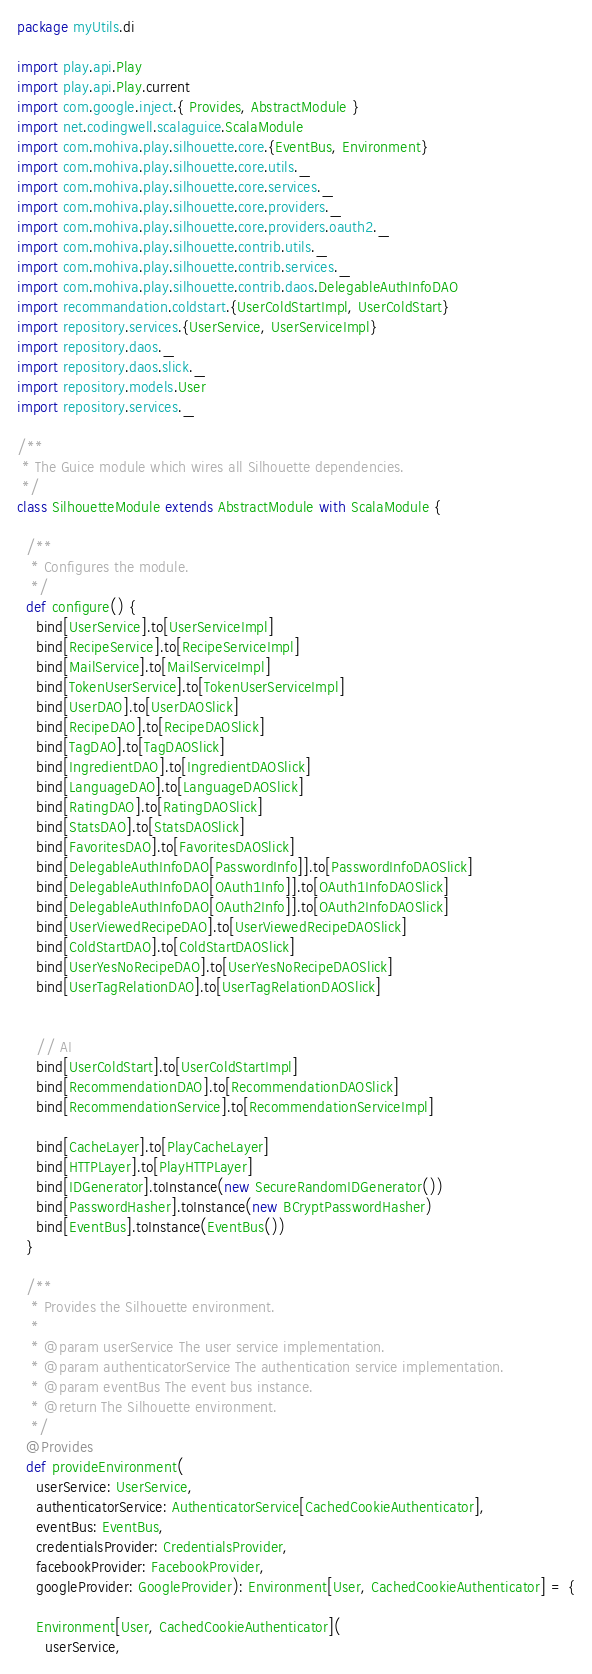Convert code to text. <code><loc_0><loc_0><loc_500><loc_500><_Scala_>package myUtils.di

import play.api.Play
import play.api.Play.current
import com.google.inject.{ Provides, AbstractModule }
import net.codingwell.scalaguice.ScalaModule
import com.mohiva.play.silhouette.core.{EventBus, Environment}
import com.mohiva.play.silhouette.core.utils._
import com.mohiva.play.silhouette.core.services._
import com.mohiva.play.silhouette.core.providers._
import com.mohiva.play.silhouette.core.providers.oauth2._
import com.mohiva.play.silhouette.contrib.utils._
import com.mohiva.play.silhouette.contrib.services._
import com.mohiva.play.silhouette.contrib.daos.DelegableAuthInfoDAO
import recommandation.coldstart.{UserColdStartImpl, UserColdStart}
import repository.services.{UserService, UserServiceImpl}
import repository.daos._
import repository.daos.slick._
import repository.models.User
import repository.services._

/**
 * The Guice module which wires all Silhouette dependencies.
 */
class SilhouetteModule extends AbstractModule with ScalaModule {

  /**
   * Configures the module.
   */
  def configure() {
    bind[UserService].to[UserServiceImpl]
    bind[RecipeService].to[RecipeServiceImpl]
    bind[MailService].to[MailServiceImpl]
    bind[TokenUserService].to[TokenUserServiceImpl]
    bind[UserDAO].to[UserDAOSlick]
    bind[RecipeDAO].to[RecipeDAOSlick]
    bind[TagDAO].to[TagDAOSlick]
    bind[IngredientDAO].to[IngredientDAOSlick]
    bind[LanguageDAO].to[LanguageDAOSlick]
    bind[RatingDAO].to[RatingDAOSlick]
    bind[StatsDAO].to[StatsDAOSlick]
    bind[FavoritesDAO].to[FavoritesDAOSlick]
    bind[DelegableAuthInfoDAO[PasswordInfo]].to[PasswordInfoDAOSlick]
    bind[DelegableAuthInfoDAO[OAuth1Info]].to[OAuth1InfoDAOSlick]
    bind[DelegableAuthInfoDAO[OAuth2Info]].to[OAuth2InfoDAOSlick]
    bind[UserViewedRecipeDAO].to[UserViewedRecipeDAOSlick]
    bind[ColdStartDAO].to[ColdStartDAOSlick]
    bind[UserYesNoRecipeDAO].to[UserYesNoRecipeDAOSlick]
    bind[UserTagRelationDAO].to[UserTagRelationDAOSlick]


    // AI
    bind[UserColdStart].to[UserColdStartImpl]
    bind[RecommendationDAO].to[RecommendationDAOSlick]
    bind[RecommendationService].to[RecommendationServiceImpl]

    bind[CacheLayer].to[PlayCacheLayer]
    bind[HTTPLayer].to[PlayHTTPLayer]
    bind[IDGenerator].toInstance(new SecureRandomIDGenerator())
    bind[PasswordHasher].toInstance(new BCryptPasswordHasher)
    bind[EventBus].toInstance(EventBus())
  }

  /**
   * Provides the Silhouette environment.
   *
   * @param userService The user service implementation.
   * @param authenticatorService The authentication service implementation.
   * @param eventBus The event bus instance.
   * @return The Silhouette environment.
   */
  @Provides
  def provideEnvironment(
    userService: UserService,
    authenticatorService: AuthenticatorService[CachedCookieAuthenticator],
    eventBus: EventBus,
    credentialsProvider: CredentialsProvider,
    facebookProvider: FacebookProvider,
    googleProvider: GoogleProvider): Environment[User, CachedCookieAuthenticator] = {

    Environment[User, CachedCookieAuthenticator](
      userService,</code> 